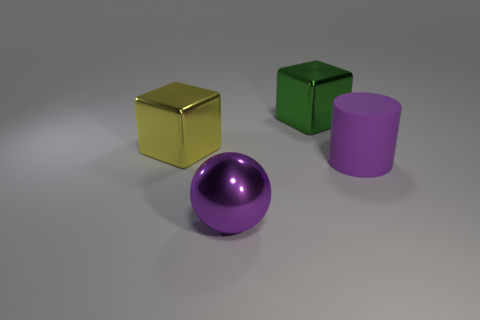What number of matte things are either green cubes or big purple things?
Make the answer very short. 1. There is a large yellow object that is made of the same material as the big sphere; what is its shape?
Provide a succinct answer. Cube. What number of large things are right of the yellow thing and behind the large ball?
Your answer should be compact. 2. Is there any other thing that has the same shape as the large rubber object?
Your answer should be very brief. No. There is a green metallic thing that is behind the yellow metallic block; what size is it?
Offer a terse response. Large. What material is the large object to the right of the shiny block to the right of the big purple metal sphere made of?
Your response must be concise. Rubber. There is a metallic object in front of the purple matte cylinder; is it the same color as the matte thing?
Make the answer very short. Yes. Are there any other things that are made of the same material as the cylinder?
Ensure brevity in your answer.  No. How many tiny cyan metallic things are the same shape as the big green object?
Give a very brief answer. 0. There is a yellow cube that is the same material as the big green object; what size is it?
Give a very brief answer. Large. 